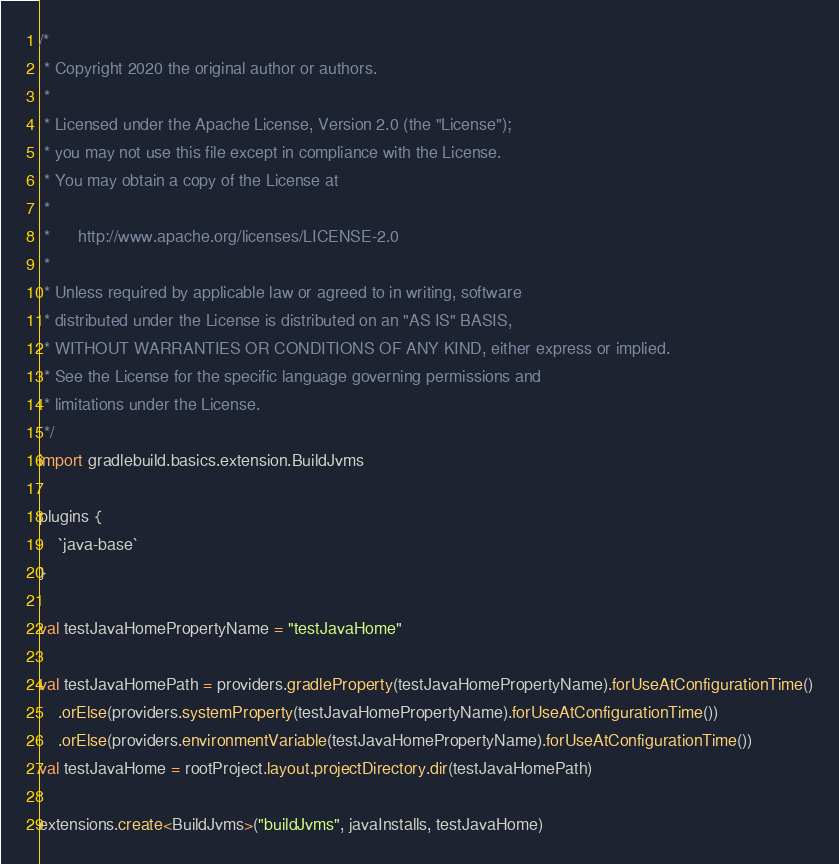Convert code to text. <code><loc_0><loc_0><loc_500><loc_500><_Kotlin_>/*
 * Copyright 2020 the original author or authors.
 *
 * Licensed under the Apache License, Version 2.0 (the "License");
 * you may not use this file except in compliance with the License.
 * You may obtain a copy of the License at
 *
 *      http://www.apache.org/licenses/LICENSE-2.0
 *
 * Unless required by applicable law or agreed to in writing, software
 * distributed under the License is distributed on an "AS IS" BASIS,
 * WITHOUT WARRANTIES OR CONDITIONS OF ANY KIND, either express or implied.
 * See the License for the specific language governing permissions and
 * limitations under the License.
 */
import gradlebuild.basics.extension.BuildJvms

plugins {
    `java-base`
}

val testJavaHomePropertyName = "testJavaHome"

val testJavaHomePath = providers.gradleProperty(testJavaHomePropertyName).forUseAtConfigurationTime()
    .orElse(providers.systemProperty(testJavaHomePropertyName).forUseAtConfigurationTime())
    .orElse(providers.environmentVariable(testJavaHomePropertyName).forUseAtConfigurationTime())
val testJavaHome = rootProject.layout.projectDirectory.dir(testJavaHomePath)

extensions.create<BuildJvms>("buildJvms", javaInstalls, testJavaHome)
</code> 